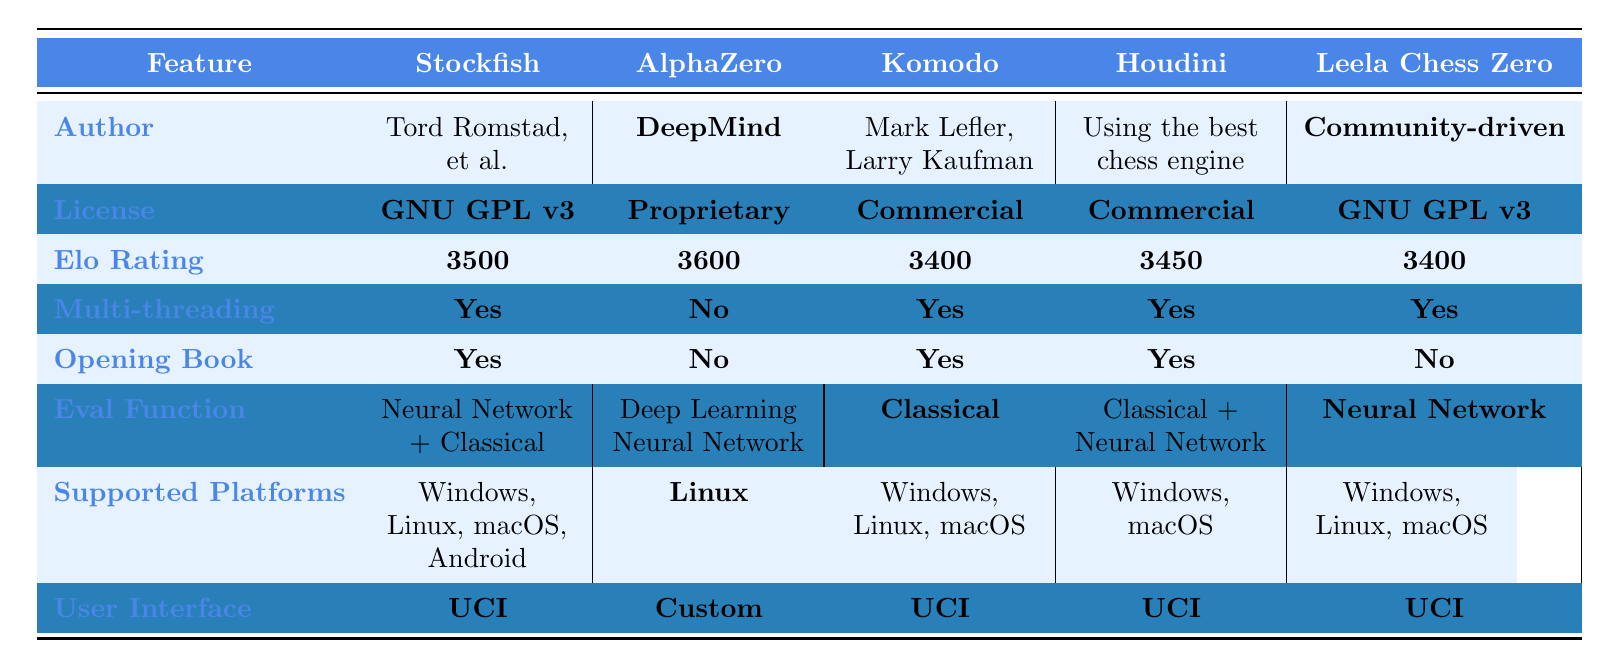What is the highest Elo rating among the chess engines? The Elo ratings for the engines are as follows: Stockfish (3500), AlphaZero (3600), Komodo (3400), Houdini (3450), and Leela Chess Zero (3400). The highest rating is 3600, which belongs to AlphaZero.
Answer: 3600 Which chess engines support multi-threading? By examining the multi-threading column, Stockfish, Komodo, Houdini, and Leela Chess Zero all have "Yes" listed under multi-threading. Only AlphaZero has "No".
Answer: Stockfish, Komodo, Houdini, Leela Chess Zero What is the license of Leela Chess Zero? The license for Leela Chess Zero is explicitly listed as GNU GPL v3 in the table.
Answer: GNU GPL v3 How many chess engines have an opening book? The engines with an opening book are Stockfish, Komodo, and Houdini (3 engines in total). AlphaZero and Leela Chess Zero do not have an opening book.
Answer: 3 Which chess engine is developed by a community-driven project? The author of Leela Chess Zero is noted as "Community-driven Project," identifying it as the engine developed by a community.
Answer: Leela Chess Zero Is it true that all the engines use a Neural Network in their evaluation function? Checking the eval function for each engine shows that only Stockfish (Neural Network + Classical), AlphaZero (Deep Learning Neural Network), Houdini (Classical + Neural Network), and Leela Chess Zero (Neural Network) use Neural Networks. Komodo uses a Classical eval function, so the statement is false.
Answer: No Which chess engine supports the most platforms? The supported platforms for each engine are listed: Stockfish supports Windows, Linux, macOS, and Android; Komodo supports Windows, Linux, and macOS; Houdini supports Windows and macOS; and Leela Chess Zero supports Windows, Linux, and macOS. Stockfish has the most platforms with four.
Answer: Stockfish What is the average Elo rating of engines using a Neural Network? The engines that use a Neural Network are Stockfish (3500), AlphaZero (3600), Houdini (3450), and Leela Chess Zero (3400). The average rating is (3500 + 3600 + 3450 + 3400) / 4 = 3487.5.
Answer: 3487.5 How many chess engines are licensed commercially? The table shows that Komodo and Houdini are licensed as Commercial. Therefore, there are two engines with a commercial license.
Answer: 2 Which engine has the lowest Elo rating? By comparing the Elo ratings, Komodo (3400) and Leela Chess Zero (3400) both have the lowest rating, but since they are the same, there is a tie.
Answer: Komodo and Leela Chess Zero 